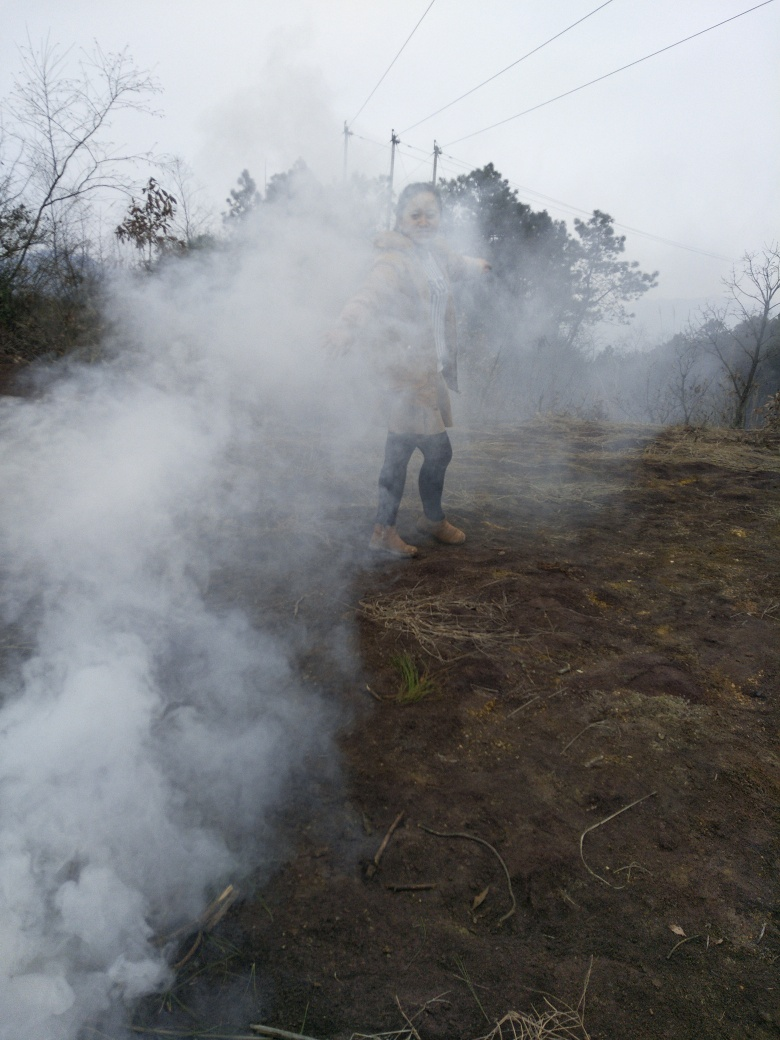Does the ground lack any texture details?
A. Yes
B. No
Answer with the option's letter from the given choices directly.
 B. 